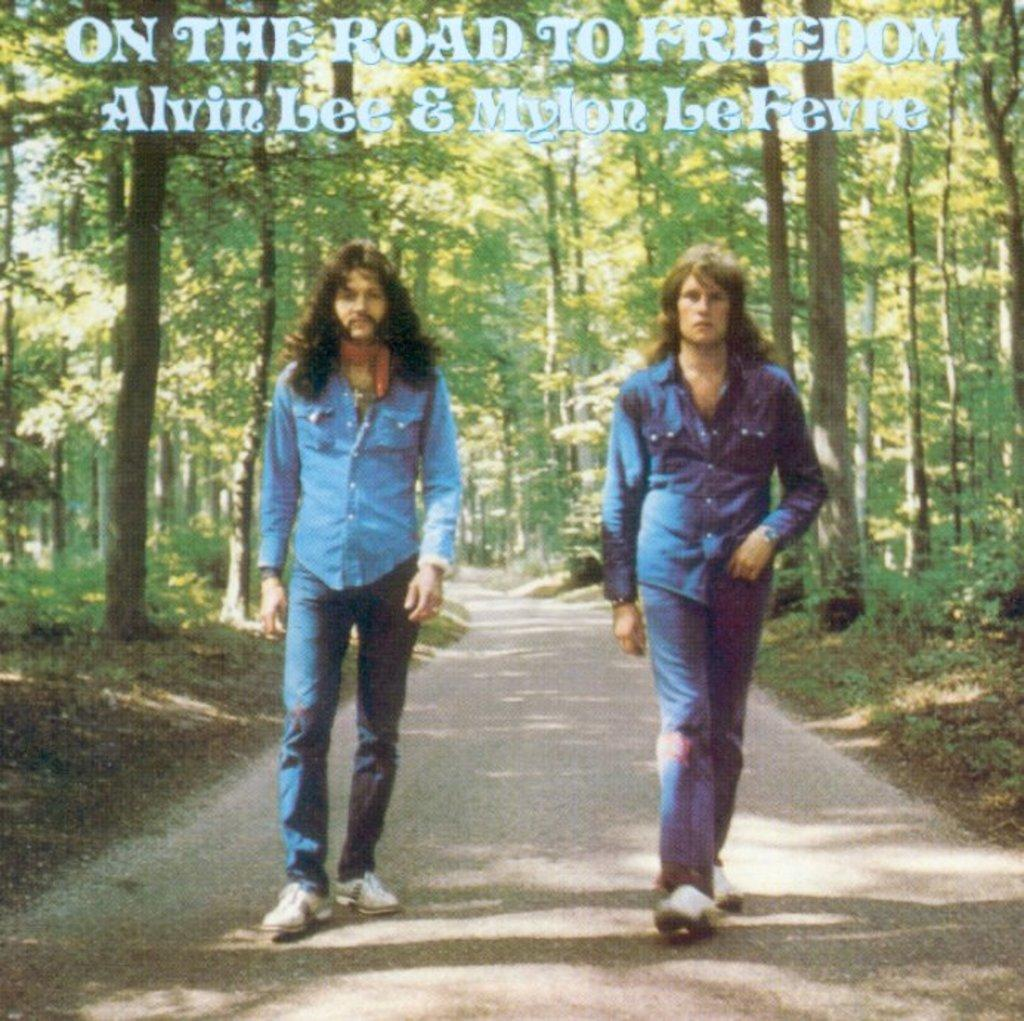How many people are in the image? There are two persons in the image. What are the persons doing in the image? The persons are walking on the road. What can be seen in the background of the image? There are trees in the background of the image. Is there any text present in the image? Yes, there is text visible on the image. What type of army uniform can be seen on the person walking on the side of the road? There is no army uniform or person walking on the side of the road in the image. What kind of patch is visible on the person's clothing in the image? There is no patch visible on the person's clothing in the image. 